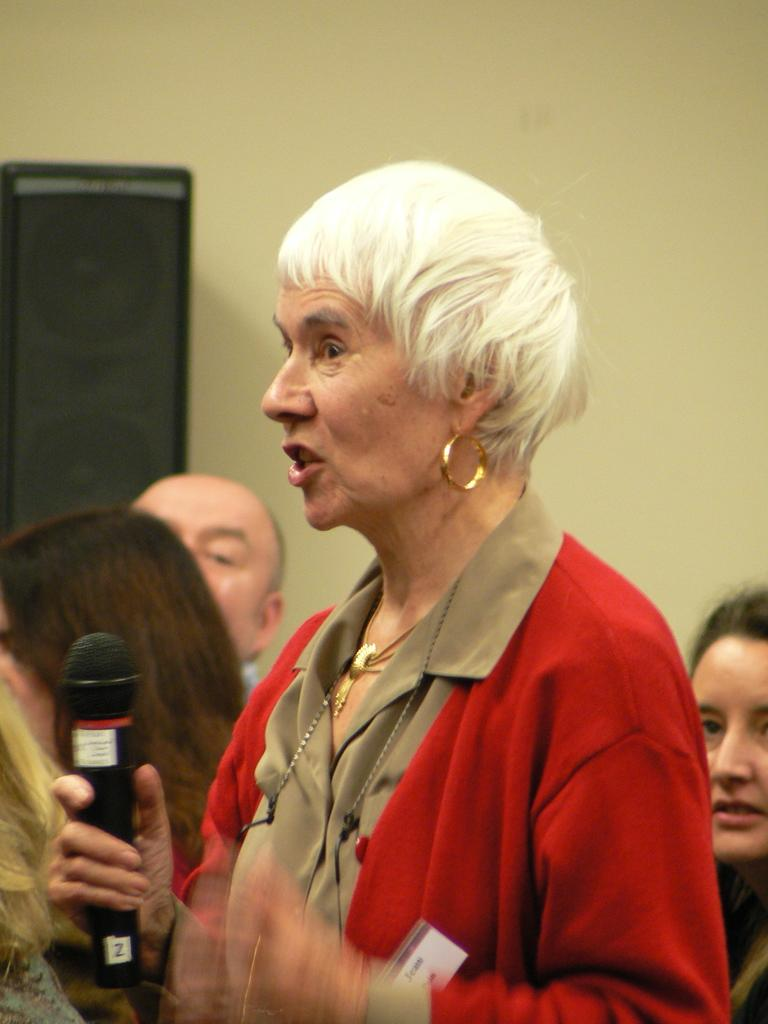What is the lady in the image wearing? The lady is wearing a red dress. What accessories is the lady wearing? The lady is wearing earrings and a chain. What is the lady holding in the image? The lady is holding a mic. What is the lady doing in the image? The lady is talking. Can you describe the background of the image? There are persons in the background of the image, and there is a wall. How many apples can be seen on the wall in the image? There are no apples present in the image; the wall is part of the background and does not have any apples on it. 